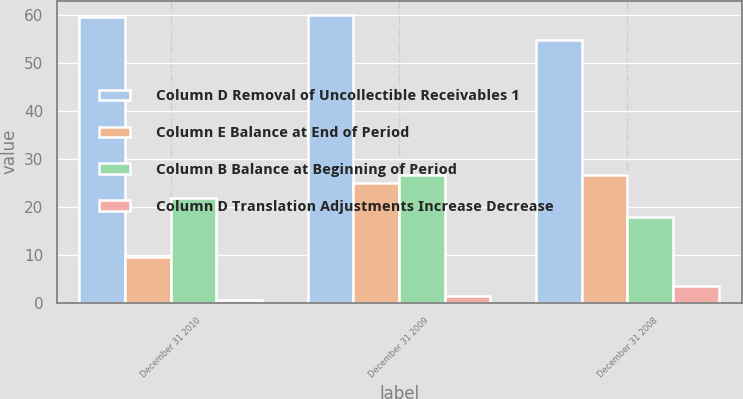Convert chart. <chart><loc_0><loc_0><loc_500><loc_500><stacked_bar_chart><ecel><fcel>December 31 2010<fcel>December 31 2009<fcel>December 31 2008<nl><fcel>Column D Removal of Uncollectible Receivables 1<fcel>59.5<fcel>59.9<fcel>54.7<nl><fcel>Column E Balance at End of Period<fcel>9.5<fcel>24.9<fcel>26.5<nl><fcel>Column B Balance at Beginning of Period<fcel>21.8<fcel>26.7<fcel>17.9<nl><fcel>Column D Translation Adjustments Increase Decrease<fcel>0.5<fcel>1.4<fcel>3.4<nl></chart> 